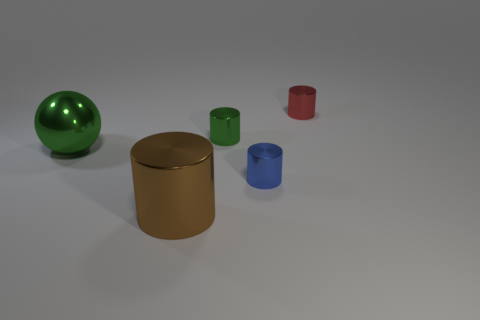Subtract all red cylinders. How many cylinders are left? 3 Add 4 green shiny objects. How many objects exist? 9 Subtract 1 balls. How many balls are left? 0 Subtract all brown cylinders. How many cylinders are left? 3 Subtract all balls. How many objects are left? 4 Add 2 balls. How many balls are left? 3 Add 5 large cubes. How many large cubes exist? 5 Subtract 0 cyan blocks. How many objects are left? 5 Subtract all red cylinders. Subtract all purple balls. How many cylinders are left? 3 Subtract all purple spheres. How many blue cylinders are left? 1 